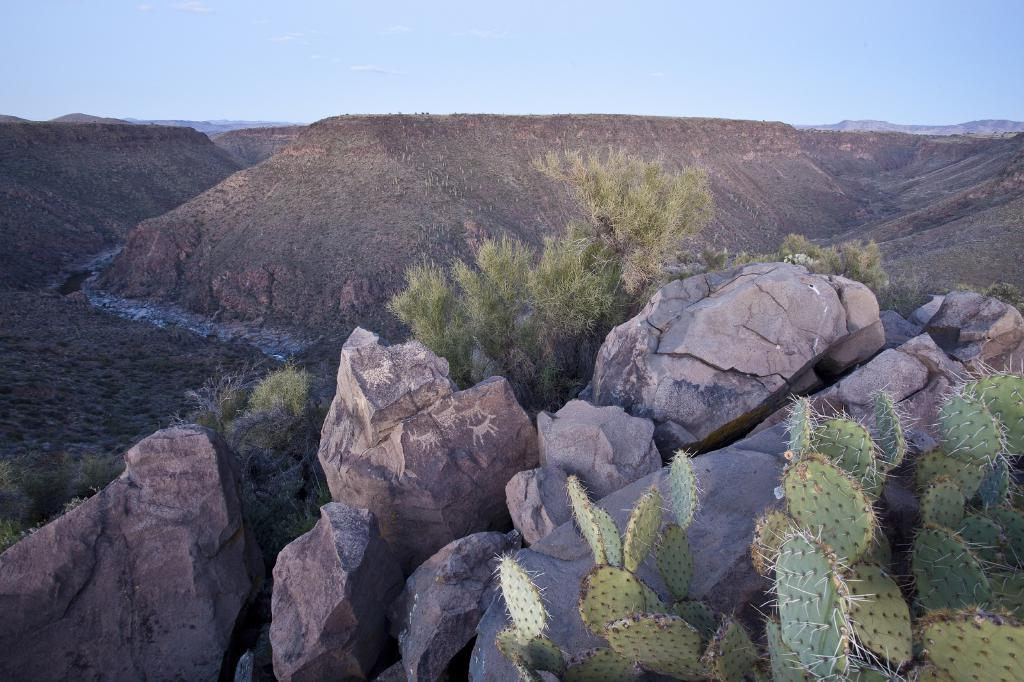What type of natural objects can be seen in the image? There are rocks and cactus plants in the image. What can be seen in the background of the image? There are trees and hills visible in the background of the image. What type of music can be heard playing in the image? There is no music present in the image; it is a still image of rocks, cactus plants, trees, and hills. 